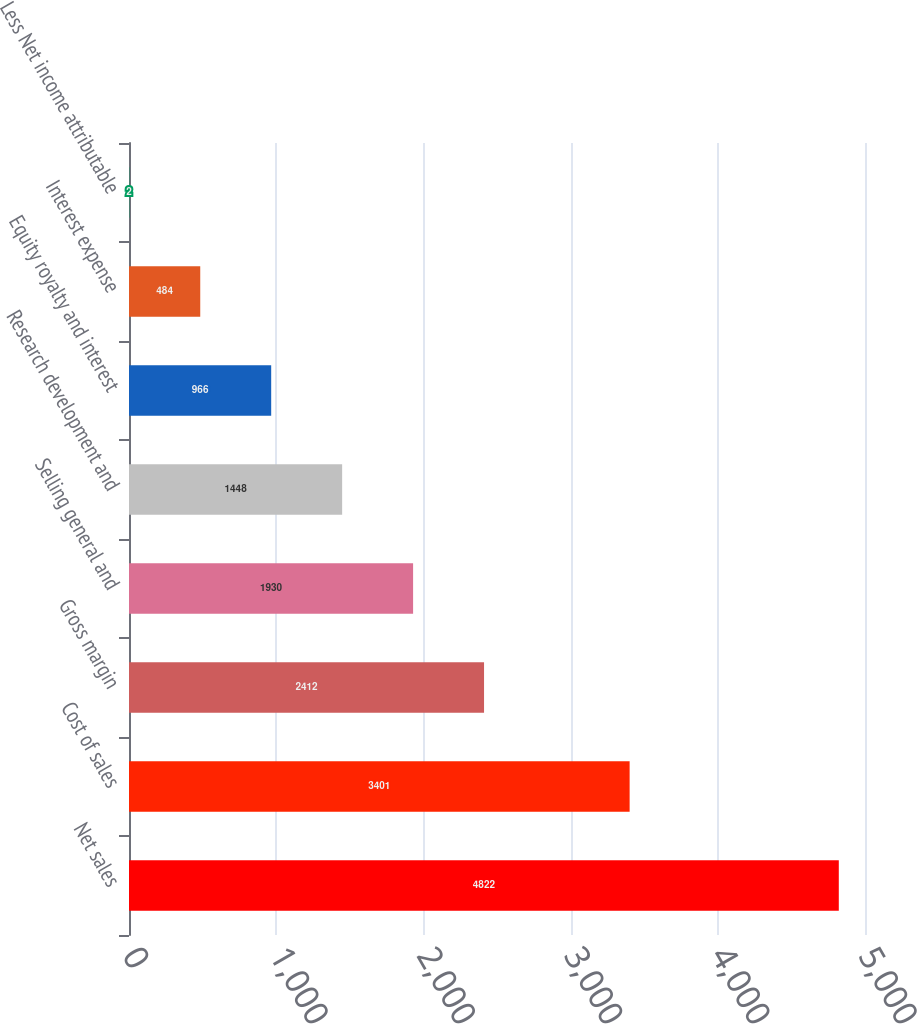Convert chart to OTSL. <chart><loc_0><loc_0><loc_500><loc_500><bar_chart><fcel>Net sales<fcel>Cost of sales<fcel>Gross margin<fcel>Selling general and<fcel>Research development and<fcel>Equity royalty and interest<fcel>Interest expense<fcel>Less Net income attributable<nl><fcel>4822<fcel>3401<fcel>2412<fcel>1930<fcel>1448<fcel>966<fcel>484<fcel>2<nl></chart> 